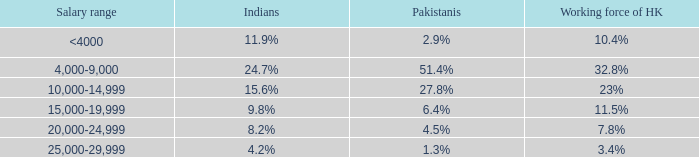Give me the full table as a dictionary. {'header': ['Salary range', 'Indians', 'Pakistanis', 'Working force of HK'], 'rows': [['<4000', '11.9%', '2.9%', '10.4%'], ['4,000-9,000', '24.7%', '51.4%', '32.8%'], ['10,000-14,999', '15.6%', '27.8%', '23%'], ['15,000-19,999', '9.8%', '6.4%', '11.5%'], ['20,000-24,999', '8.2%', '4.5%', '7.8%'], ['25,000-29,999', '4.2%', '1.3%', '3.4%']]} If the salary range is 4,000-9,000, what is the Indians %? 24.7%. 